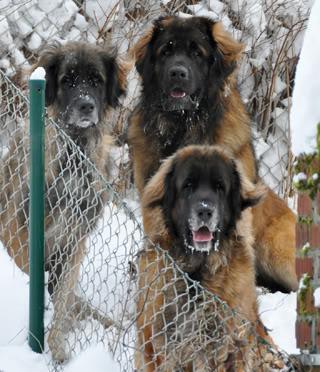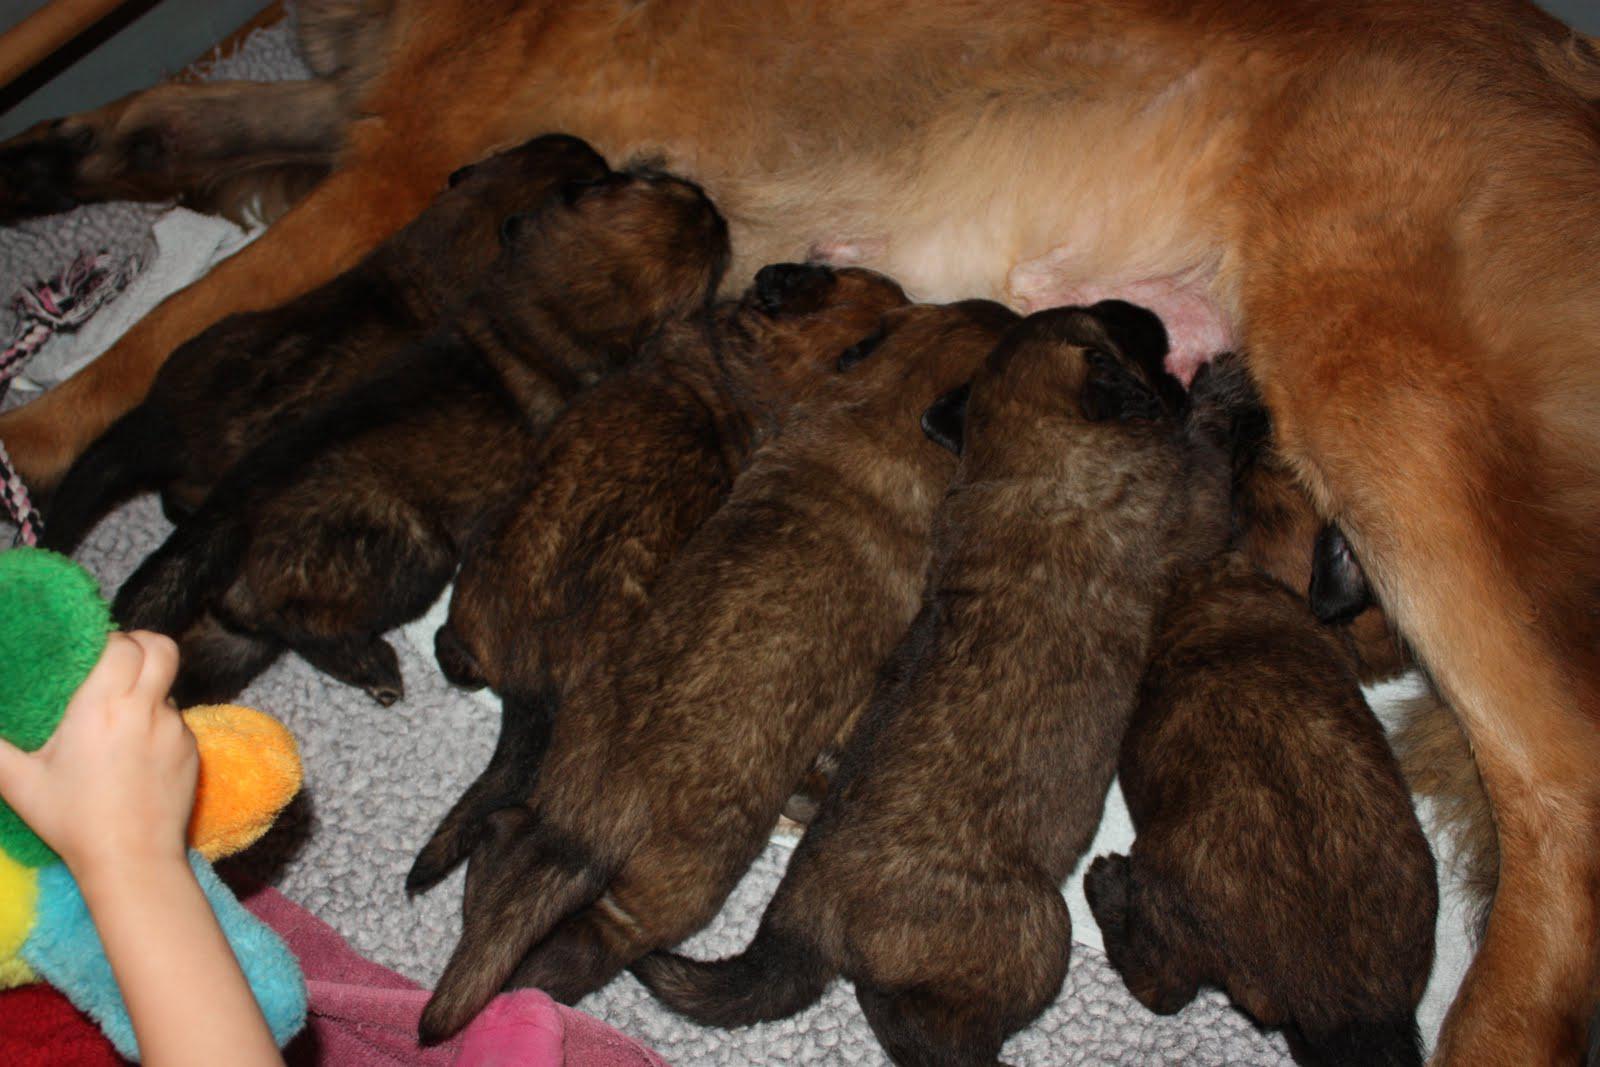The first image is the image on the left, the second image is the image on the right. For the images shown, is this caption "There is an adult dog chewing on the animal flesh." true? Answer yes or no. No. The first image is the image on the left, the second image is the image on the right. For the images displayed, is the sentence "The left image shows a reclining big-breed adult dog chewing on some type of raw meat, and the right image shows at least one big-breed puppy." factually correct? Answer yes or no. No. 